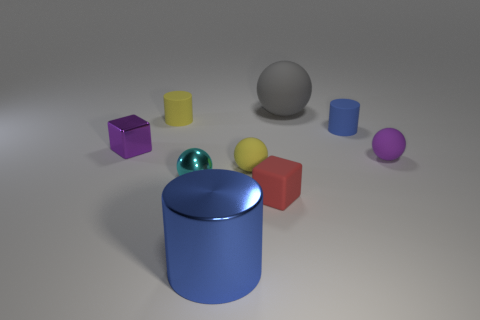Is the big thing behind the blue matte cylinder made of the same material as the cylinder that is in front of the small shiny block?
Offer a very short reply. No. There is a blue cylinder left of the cube in front of the purple matte sphere; what is it made of?
Ensure brevity in your answer.  Metal. There is a matte cylinder to the left of the block that is on the right side of the purple thing on the left side of the purple sphere; what is its size?
Your answer should be compact. Small. Is the size of the blue shiny cylinder the same as the purple block?
Keep it short and to the point. No. Do the metal object that is behind the tiny cyan metallic object and the tiny purple object right of the red cube have the same shape?
Give a very brief answer. No. Are there any matte cylinders that are to the left of the tiny yellow object behind the metallic cube?
Provide a short and direct response. No. Are any tiny gray metallic cylinders visible?
Provide a short and direct response. No. How many other shiny things have the same size as the cyan metal object?
Your answer should be compact. 1. How many matte cylinders are both right of the tiny rubber cube and left of the tiny red matte thing?
Your answer should be compact. 0. Does the block that is on the right side of the metallic cube have the same size as the cyan shiny object?
Make the answer very short. Yes. 